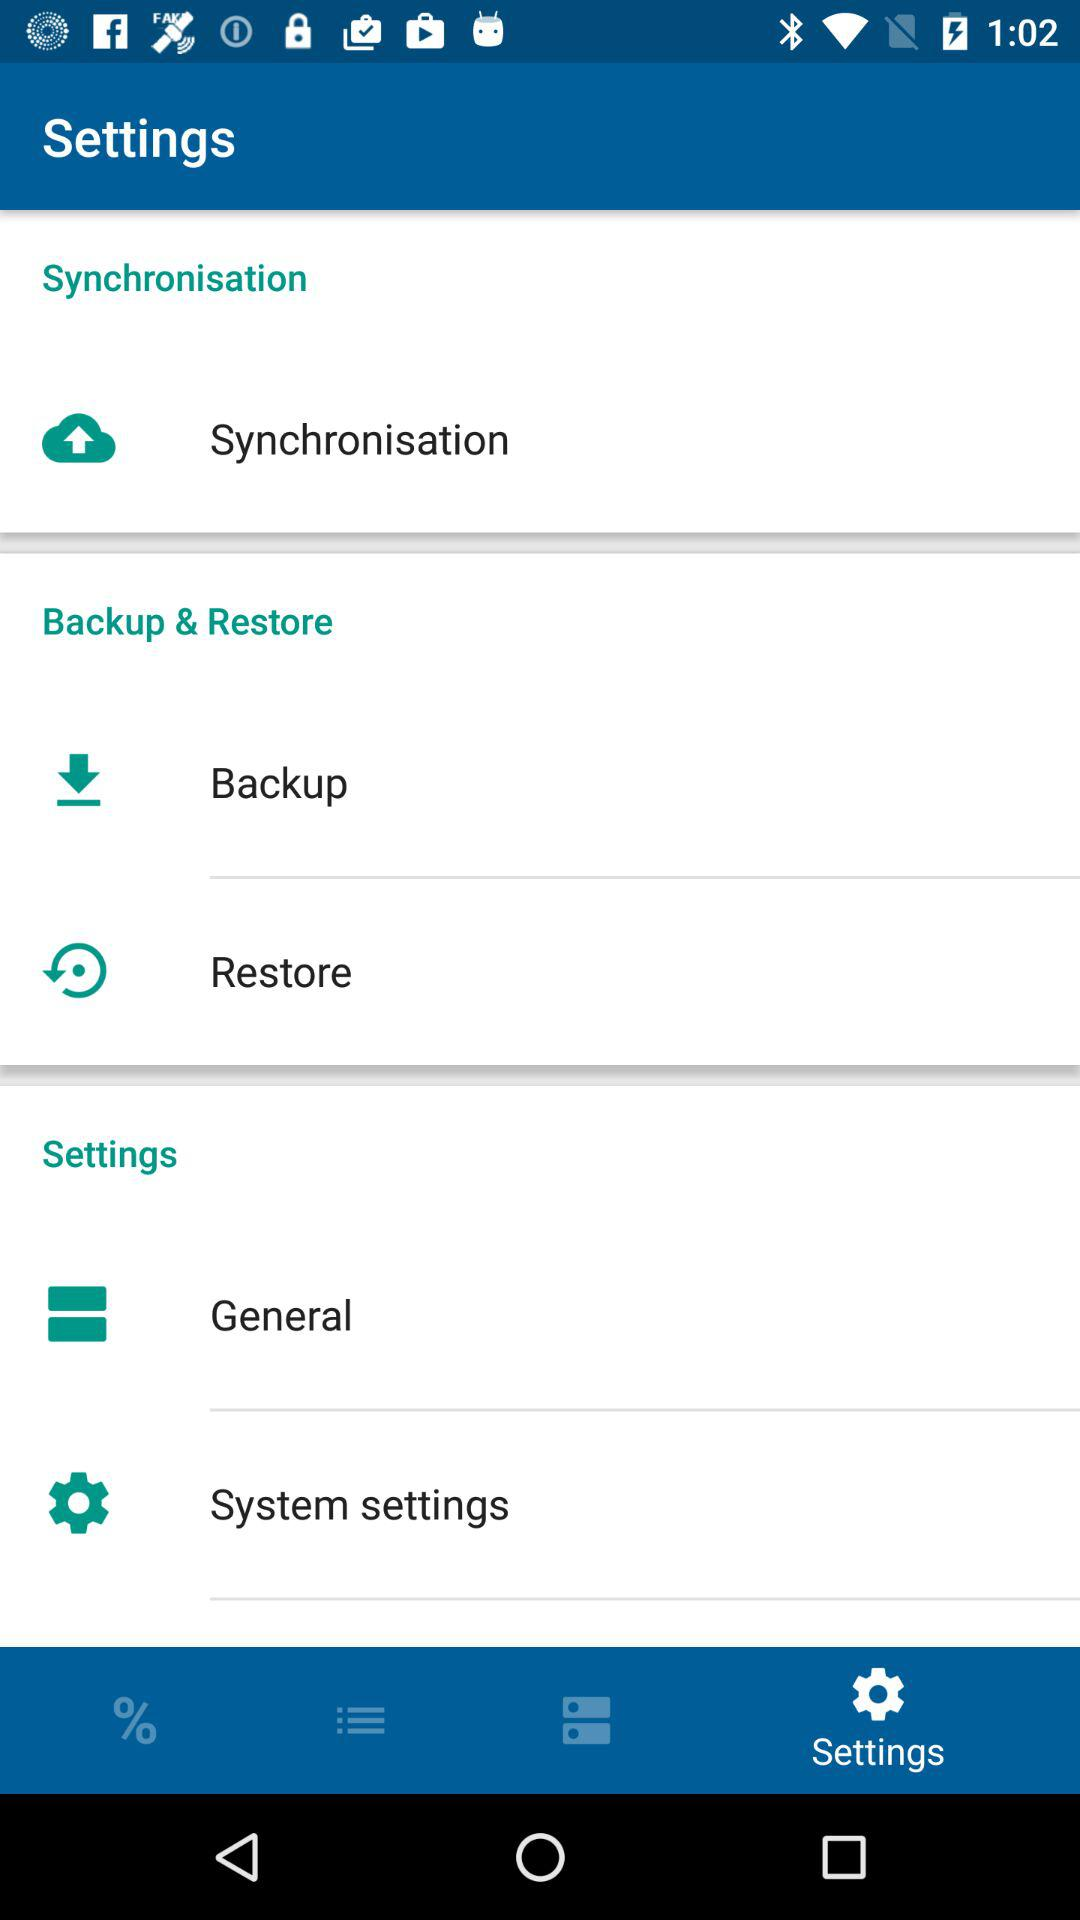Which tab is selected? The selected tab is "Settings". 